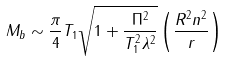Convert formula to latex. <formula><loc_0><loc_0><loc_500><loc_500>M _ { b } \sim \frac { \pi } { 4 } T _ { 1 } \sqrt { 1 + \frac { \Pi ^ { 2 } } { T _ { 1 } ^ { 2 } \lambda ^ { 2 } } } \left ( \frac { R ^ { 2 } n ^ { 2 } } { r } \right )</formula> 